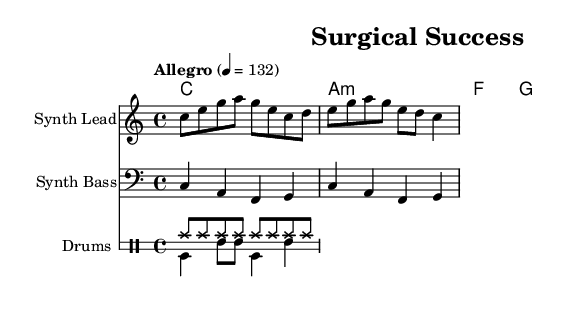What is the key signature of this music? The key signature is indicated at the beginning of the music sheet and shows no sharps or flats, which corresponds to the key of C major.
Answer: C major What is the time signature of this music? The time signature is found at the beginning of the sheet music, noted as 4/4, which indicates four beats per measure and a quarter note receives one beat.
Answer: 4/4 What is the tempo marking for this piece? The tempo is indicated in the music as "Allegro" with a specific metronome marking of 132 beats per minute, suggesting a fast and lively pace.
Answer: 132 How many instruments are featured in the score? The score includes three distinct instrumental parts: Synth Lead, Synth Bass, and Drums, each represented on separate staves for clarity.
Answer: Three What is the first note played by the Synth Lead? By examining the Synth Lead staff, we see that the first note is C, indicated on the third space of the treble clef.
Answer: C Which chord follows the C chord in the chord progression? In the chord progression section, after the C chord, the next chord noted is A minor, which is represented as A:m.
Answer: A minor What rhythmic pattern do the hi-hats follow in the drum part? Looking at the drum notation, the hi-hats have a consistent pattern of eighth notes (hihat8) played throughout the section, indicating continuous rhythm.
Answer: Eighth notes 